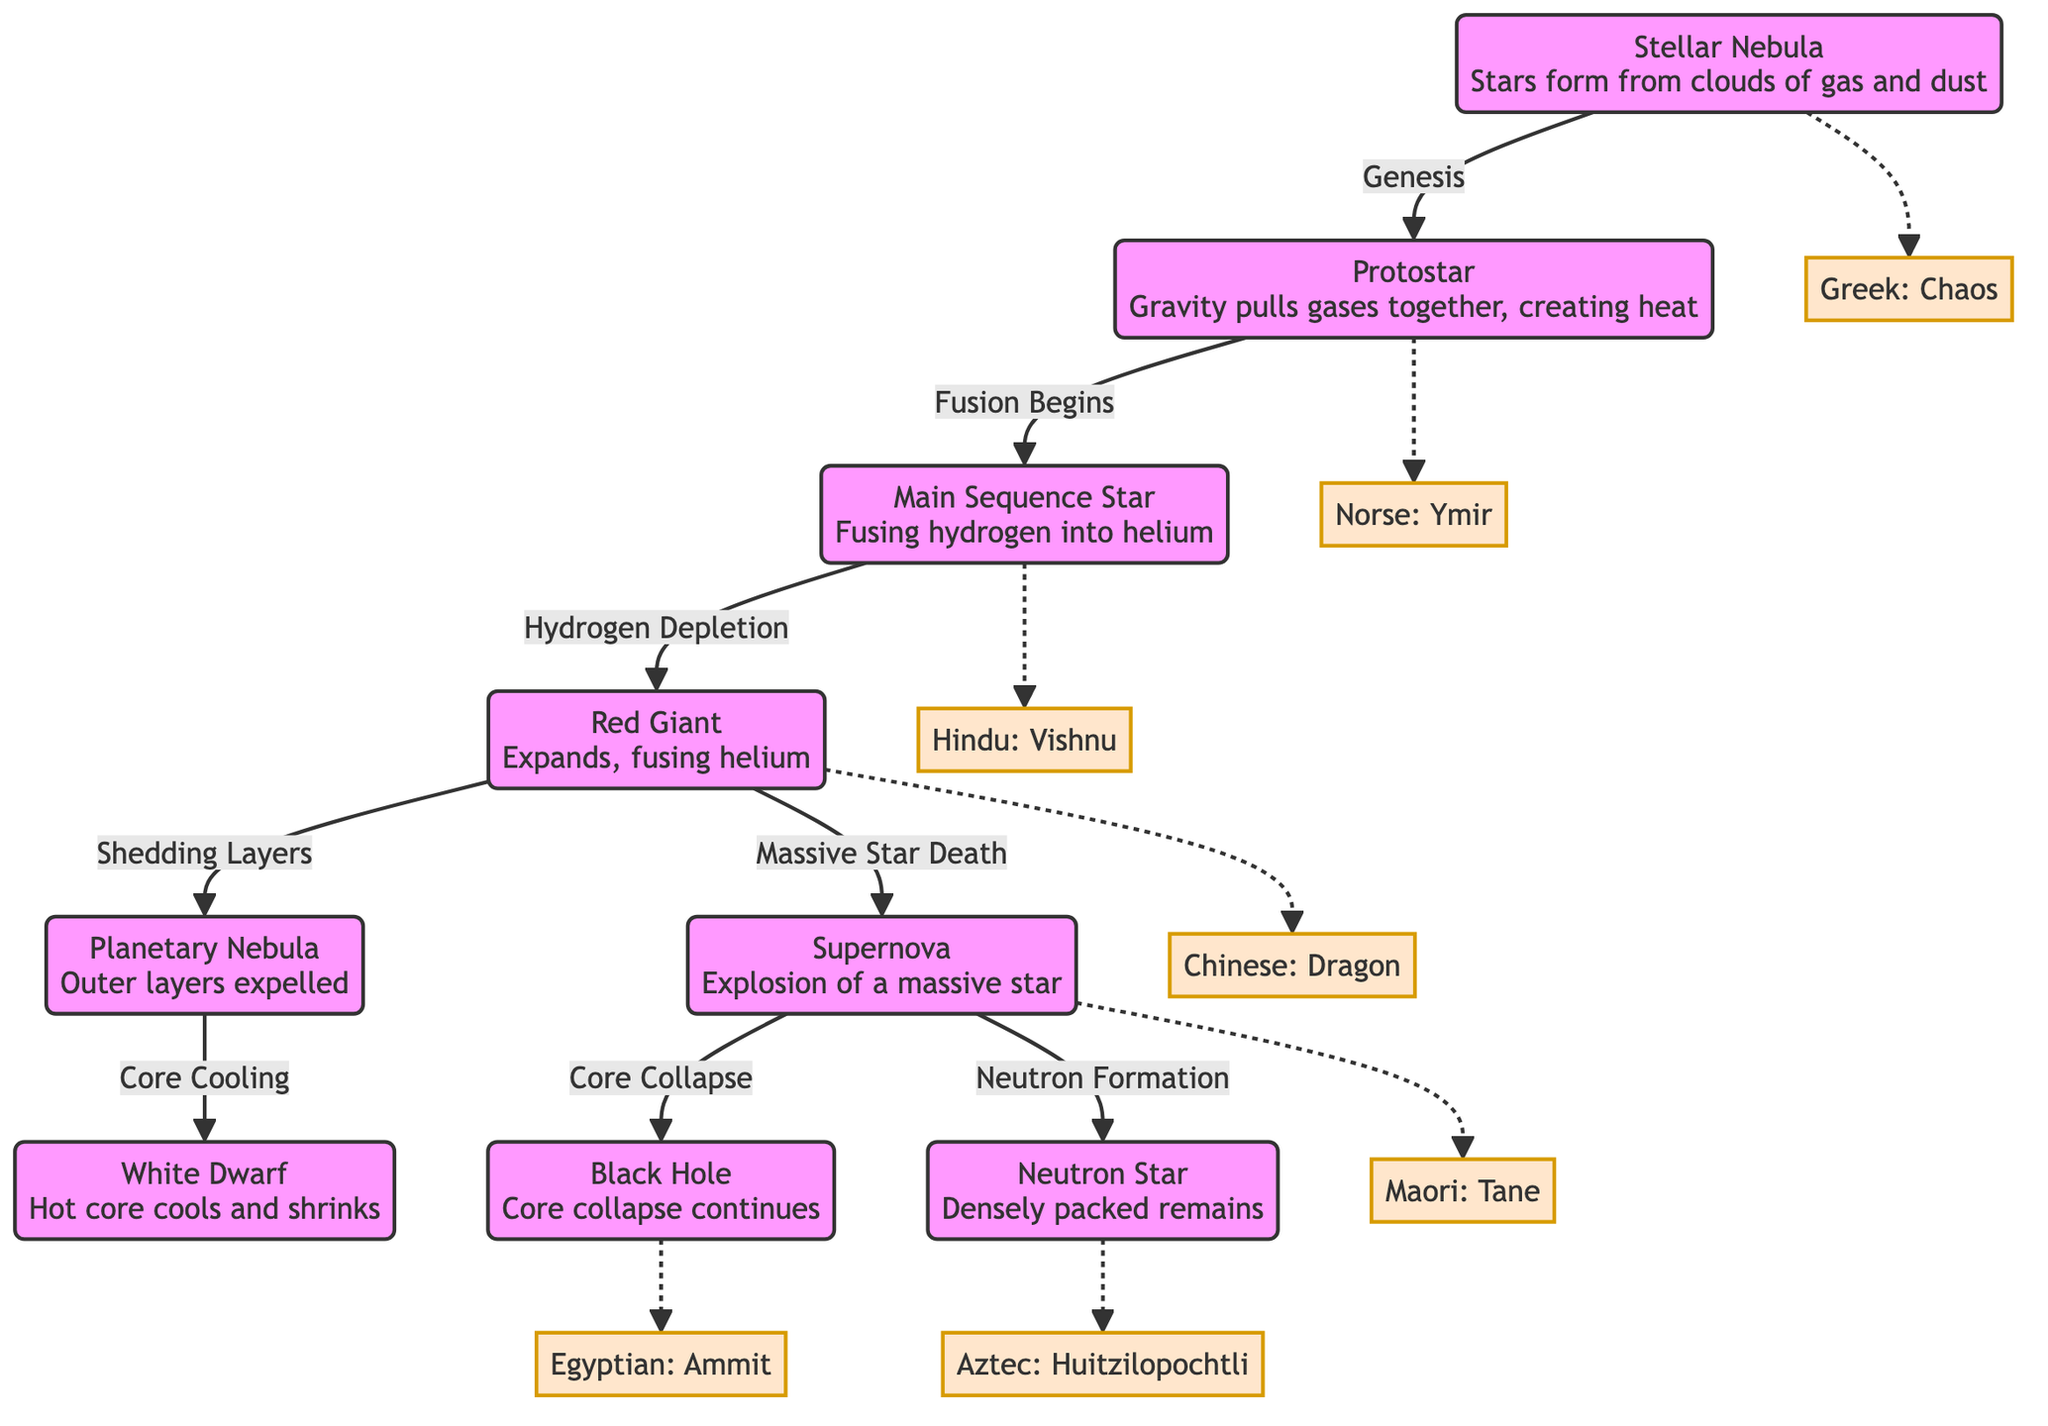What is the initial stage of a star's lifecycle? The diagram indicates that the lifecycle begins at the "Stellar Nebula" node, which describes the formation of stars from clouds of gas and dust.
Answer: Stellar Nebula How many final outcomes are there after a supernova? From the "Supernova" node, two pathways emerge, leading to either a "Black Hole" or a "Neutron Star." Therefore, there are two outcomes after a supernova.
Answer: 2 What mythological figure is connected to the red giant stage? The diagram connects the "Red Giant" stage to the mythological figure "Dragon" from Chinese mythology through a dashed line, indicating a relationship between the stage and the cultural story.
Answer: Dragon What process marks the transition from protostar to main sequence? The arrow indicates that the transition from "Protostar" to "Main Sequence Star" is marked by "Fusion Begins," signifying the start of nuclear fusion in the star's core.
Answer: Fusion Begins Which mythology is associated with the white dwarf stage? The "White Dwarf" node is linked to the Egyptian mythology figure "Ammit," indicating the cultural storytelling related to this stage of a star's lifecycle.
Answer: Ammit How does a red giant star end its life? The "Red Giant" node shows two pathways: one leads to "Supernova" (for massive stars) and the other goes to "Planetary Nebula" (for smaller stars), indicating the various endpoints for different sizes of stars.
Answer: Supernova and Planetary Nebula Which node comes after the "Main Sequence Star"? The diagram flows from the "Main Sequence Star" to the "Red Giant" node, indicating that the next stage in the lifecycle of a star after the main sequence is the red giant stage.
Answer: Red Giant 